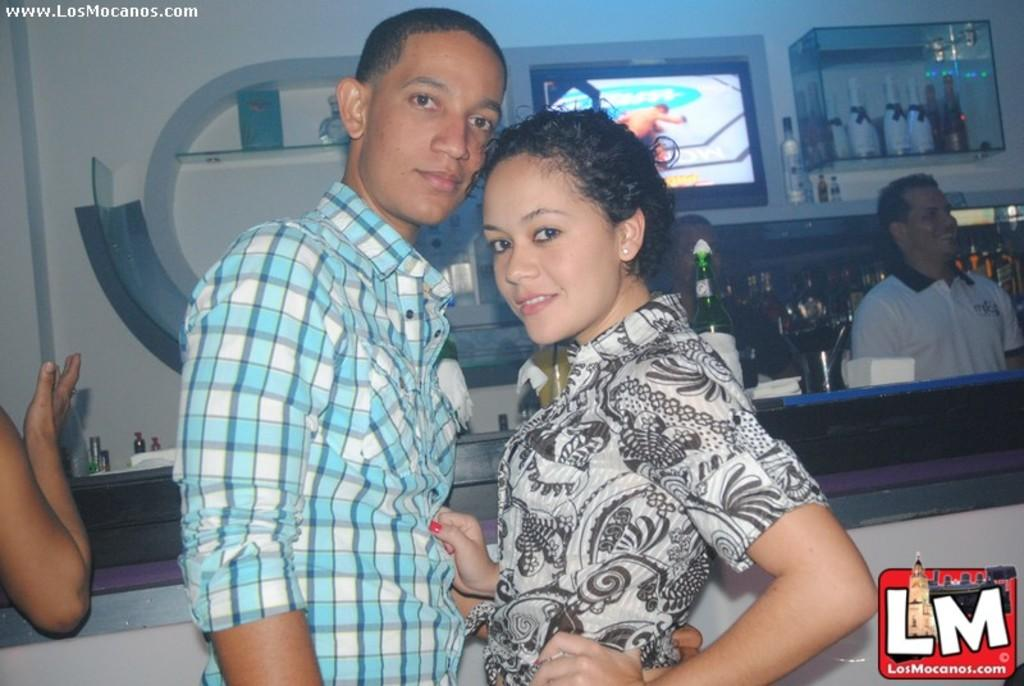What are the people in the image doing? There are people standing in the image. Can you describe their expressions? Some people have smiles on their faces. What can be seen in the background of the image? There is a television and multiple bottles visible in the background. Is there any additional information about the image itself? Yes, there is a watermark in the image. What type of treatment is being administered to the zebra in the image? There is no zebra present in the image, so no treatment is being administered. Can you describe the pickle's role in the image? There is no pickle present in the image, so it does not have a role. 